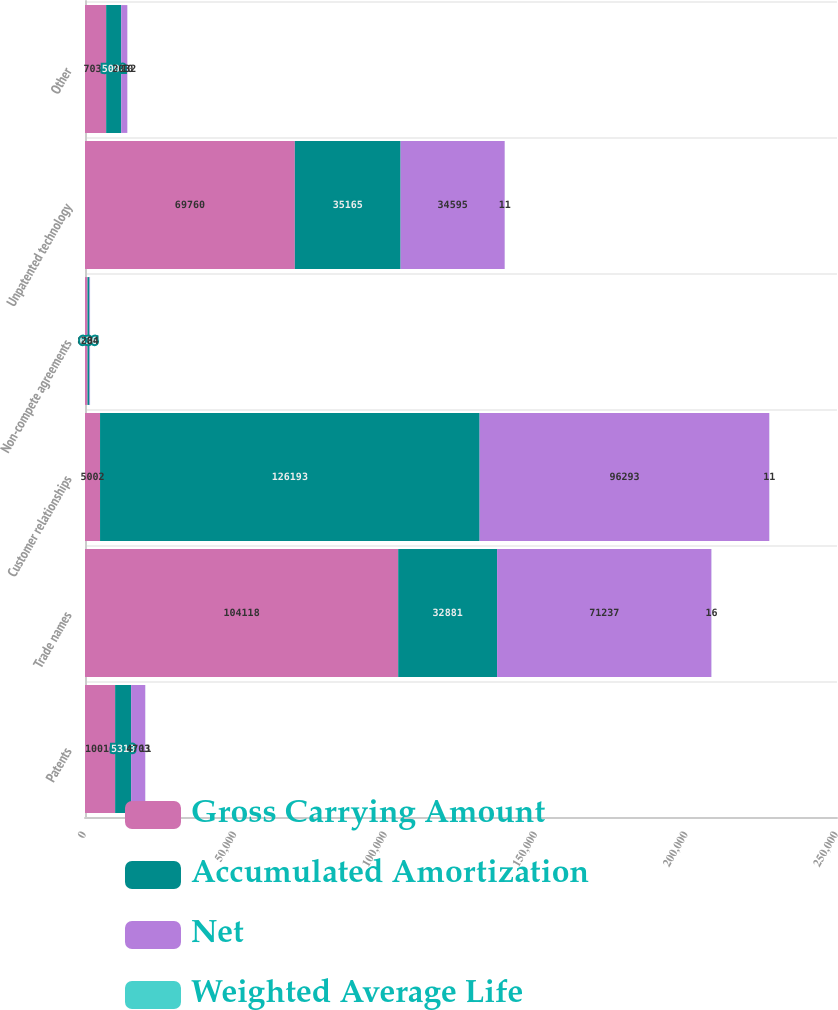Convert chart to OTSL. <chart><loc_0><loc_0><loc_500><loc_500><stacked_bar_chart><ecel><fcel>Patents<fcel>Trade names<fcel>Customer relationships<fcel>Non-compete agreements<fcel>Unpatented technology<fcel>Other<nl><fcel>Gross Carrying Amount<fcel>10016<fcel>104118<fcel>5002<fcel>840<fcel>69760<fcel>7034<nl><fcel>Accumulated Amortization<fcel>5313<fcel>32881<fcel>126193<fcel>636<fcel>35165<fcel>5002<nl><fcel>Net<fcel>4703<fcel>71237<fcel>96293<fcel>204<fcel>34595<fcel>2032<nl><fcel>Weighted Average Life<fcel>11<fcel>16<fcel>11<fcel>3<fcel>11<fcel>10<nl></chart> 